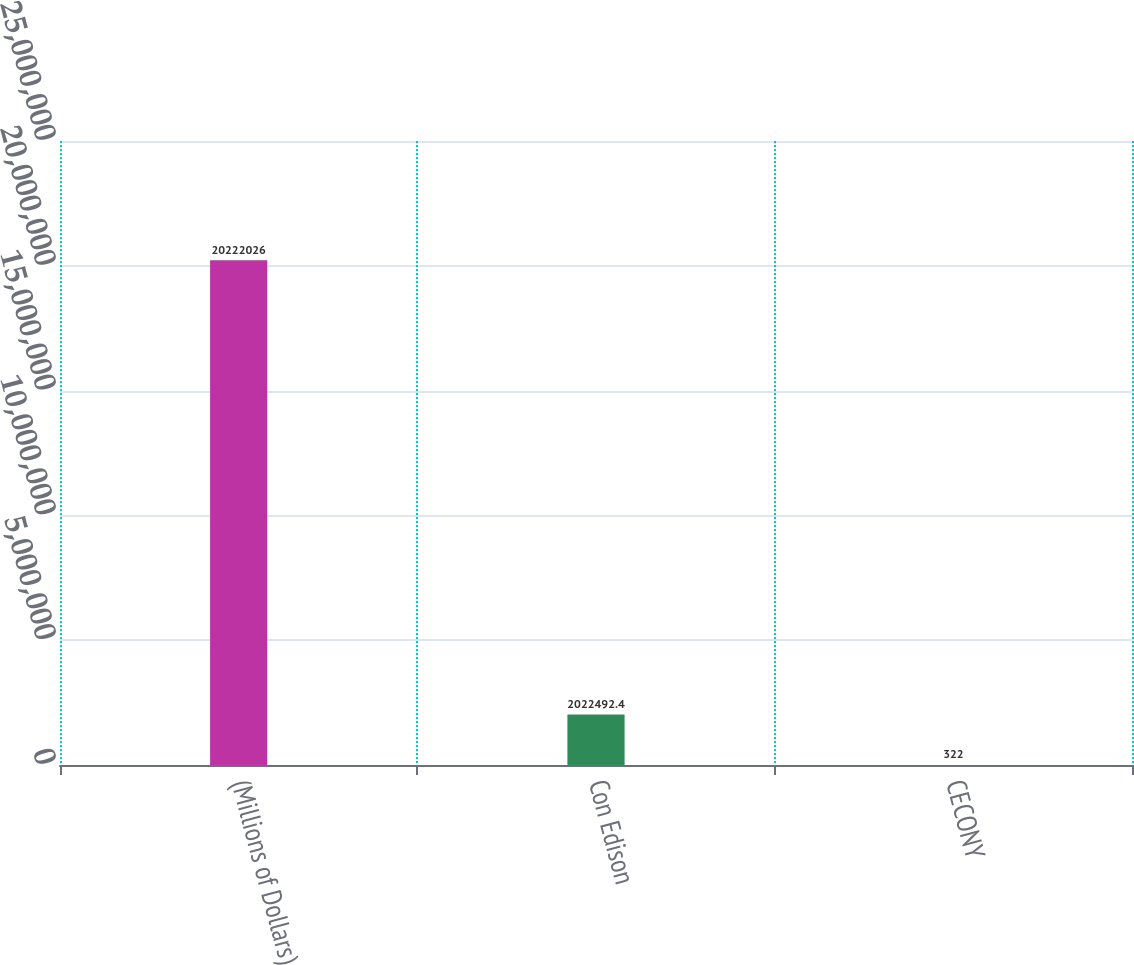Convert chart to OTSL. <chart><loc_0><loc_0><loc_500><loc_500><bar_chart><fcel>(Millions of Dollars)<fcel>Con Edison<fcel>CECONY<nl><fcel>2.0222e+07<fcel>2.02249e+06<fcel>322<nl></chart> 